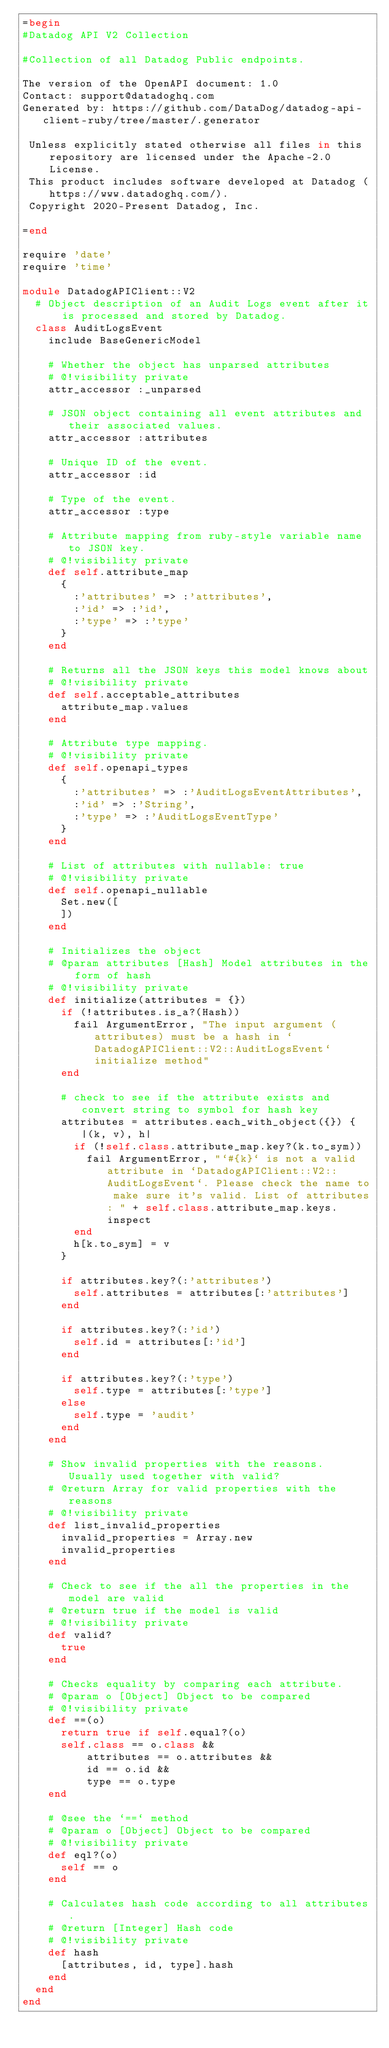<code> <loc_0><loc_0><loc_500><loc_500><_Ruby_>=begin
#Datadog API V2 Collection

#Collection of all Datadog Public endpoints.

The version of the OpenAPI document: 1.0
Contact: support@datadoghq.com
Generated by: https://github.com/DataDog/datadog-api-client-ruby/tree/master/.generator

 Unless explicitly stated otherwise all files in this repository are licensed under the Apache-2.0 License.
 This product includes software developed at Datadog (https://www.datadoghq.com/).
 Copyright 2020-Present Datadog, Inc.

=end

require 'date'
require 'time'

module DatadogAPIClient::V2
  # Object description of an Audit Logs event after it is processed and stored by Datadog.
  class AuditLogsEvent
    include BaseGenericModel

    # Whether the object has unparsed attributes
    # @!visibility private
    attr_accessor :_unparsed

    # JSON object containing all event attributes and their associated values.
    attr_accessor :attributes

    # Unique ID of the event.
    attr_accessor :id

    # Type of the event.
    attr_accessor :type

    # Attribute mapping from ruby-style variable name to JSON key.
    # @!visibility private
    def self.attribute_map
      {
        :'attributes' => :'attributes',
        :'id' => :'id',
        :'type' => :'type'
      }
    end

    # Returns all the JSON keys this model knows about
    # @!visibility private
    def self.acceptable_attributes
      attribute_map.values
    end

    # Attribute type mapping.
    # @!visibility private
    def self.openapi_types
      {
        :'attributes' => :'AuditLogsEventAttributes',
        :'id' => :'String',
        :'type' => :'AuditLogsEventType'
      }
    end

    # List of attributes with nullable: true
    # @!visibility private
    def self.openapi_nullable
      Set.new([
      ])
    end

    # Initializes the object
    # @param attributes [Hash] Model attributes in the form of hash
    # @!visibility private
    def initialize(attributes = {})
      if (!attributes.is_a?(Hash))
        fail ArgumentError, "The input argument (attributes) must be a hash in `DatadogAPIClient::V2::AuditLogsEvent` initialize method"
      end

      # check to see if the attribute exists and convert string to symbol for hash key
      attributes = attributes.each_with_object({}) { |(k, v), h|
        if (!self.class.attribute_map.key?(k.to_sym))
          fail ArgumentError, "`#{k}` is not a valid attribute in `DatadogAPIClient::V2::AuditLogsEvent`. Please check the name to make sure it's valid. List of attributes: " + self.class.attribute_map.keys.inspect
        end
        h[k.to_sym] = v
      }

      if attributes.key?(:'attributes')
        self.attributes = attributes[:'attributes']
      end

      if attributes.key?(:'id')
        self.id = attributes[:'id']
      end

      if attributes.key?(:'type')
        self.type = attributes[:'type']
      else
        self.type = 'audit'
      end
    end

    # Show invalid properties with the reasons. Usually used together with valid?
    # @return Array for valid properties with the reasons
    # @!visibility private
    def list_invalid_properties
      invalid_properties = Array.new
      invalid_properties
    end

    # Check to see if the all the properties in the model are valid
    # @return true if the model is valid
    # @!visibility private
    def valid?
      true
    end

    # Checks equality by comparing each attribute.
    # @param o [Object] Object to be compared
    # @!visibility private
    def ==(o)
      return true if self.equal?(o)
      self.class == o.class &&
          attributes == o.attributes &&
          id == o.id &&
          type == o.type
    end

    # @see the `==` method
    # @param o [Object] Object to be compared
    # @!visibility private
    def eql?(o)
      self == o
    end

    # Calculates hash code according to all attributes.
    # @return [Integer] Hash code
    # @!visibility private
    def hash
      [attributes, id, type].hash
    end
  end
end
</code> 